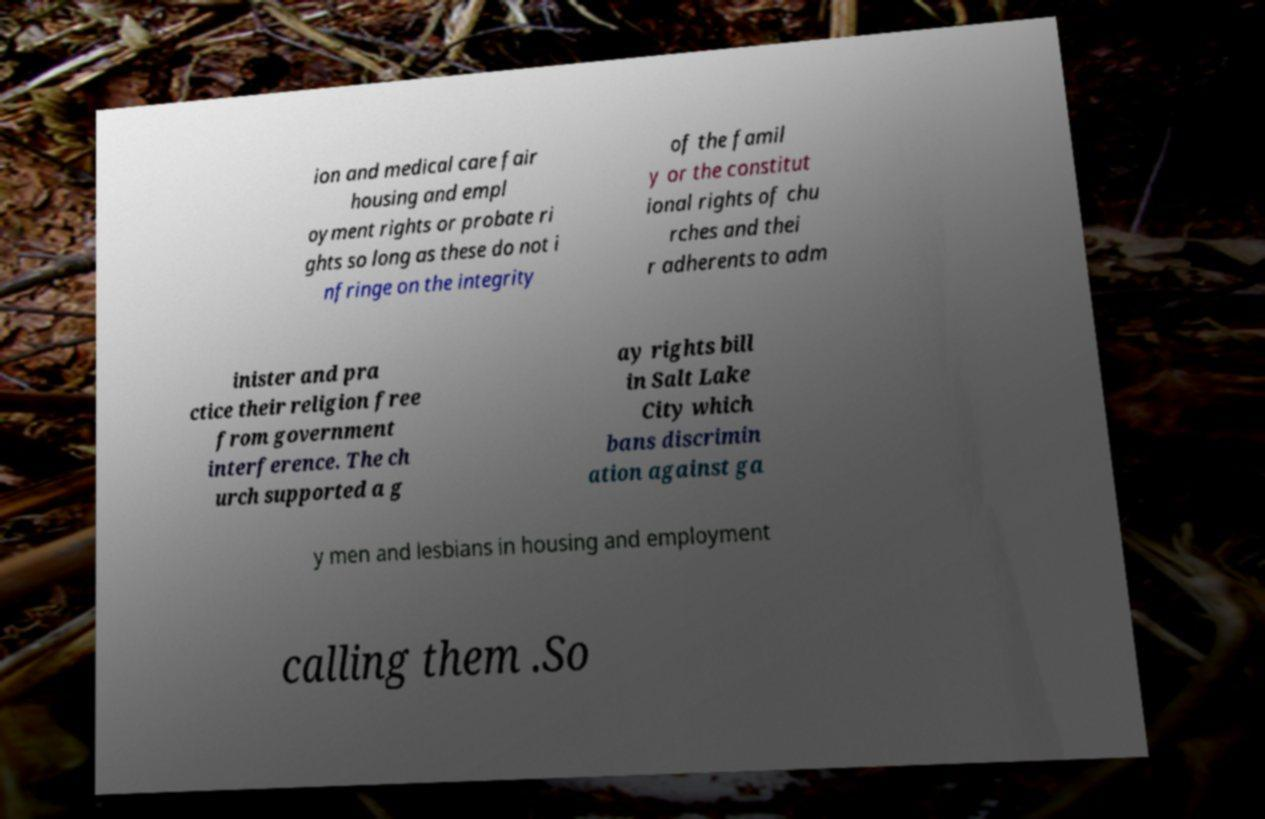What messages or text are displayed in this image? I need them in a readable, typed format. ion and medical care fair housing and empl oyment rights or probate ri ghts so long as these do not i nfringe on the integrity of the famil y or the constitut ional rights of chu rches and thei r adherents to adm inister and pra ctice their religion free from government interference. The ch urch supported a g ay rights bill in Salt Lake City which bans discrimin ation against ga y men and lesbians in housing and employment calling them .So 